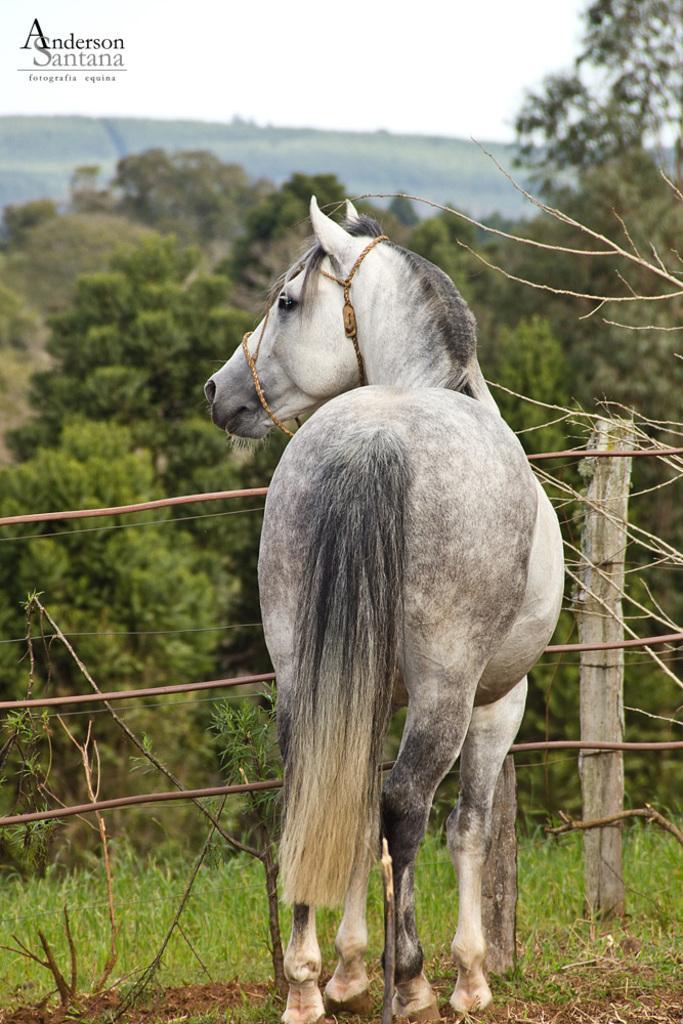Could you give a brief overview of what you see in this image? In this picture there is a white horse standing near to the fencing. In the background we can see mountains and trees. At the top there is a sky. At the bottom we can see grass. On the top left corner there is a watermark. 